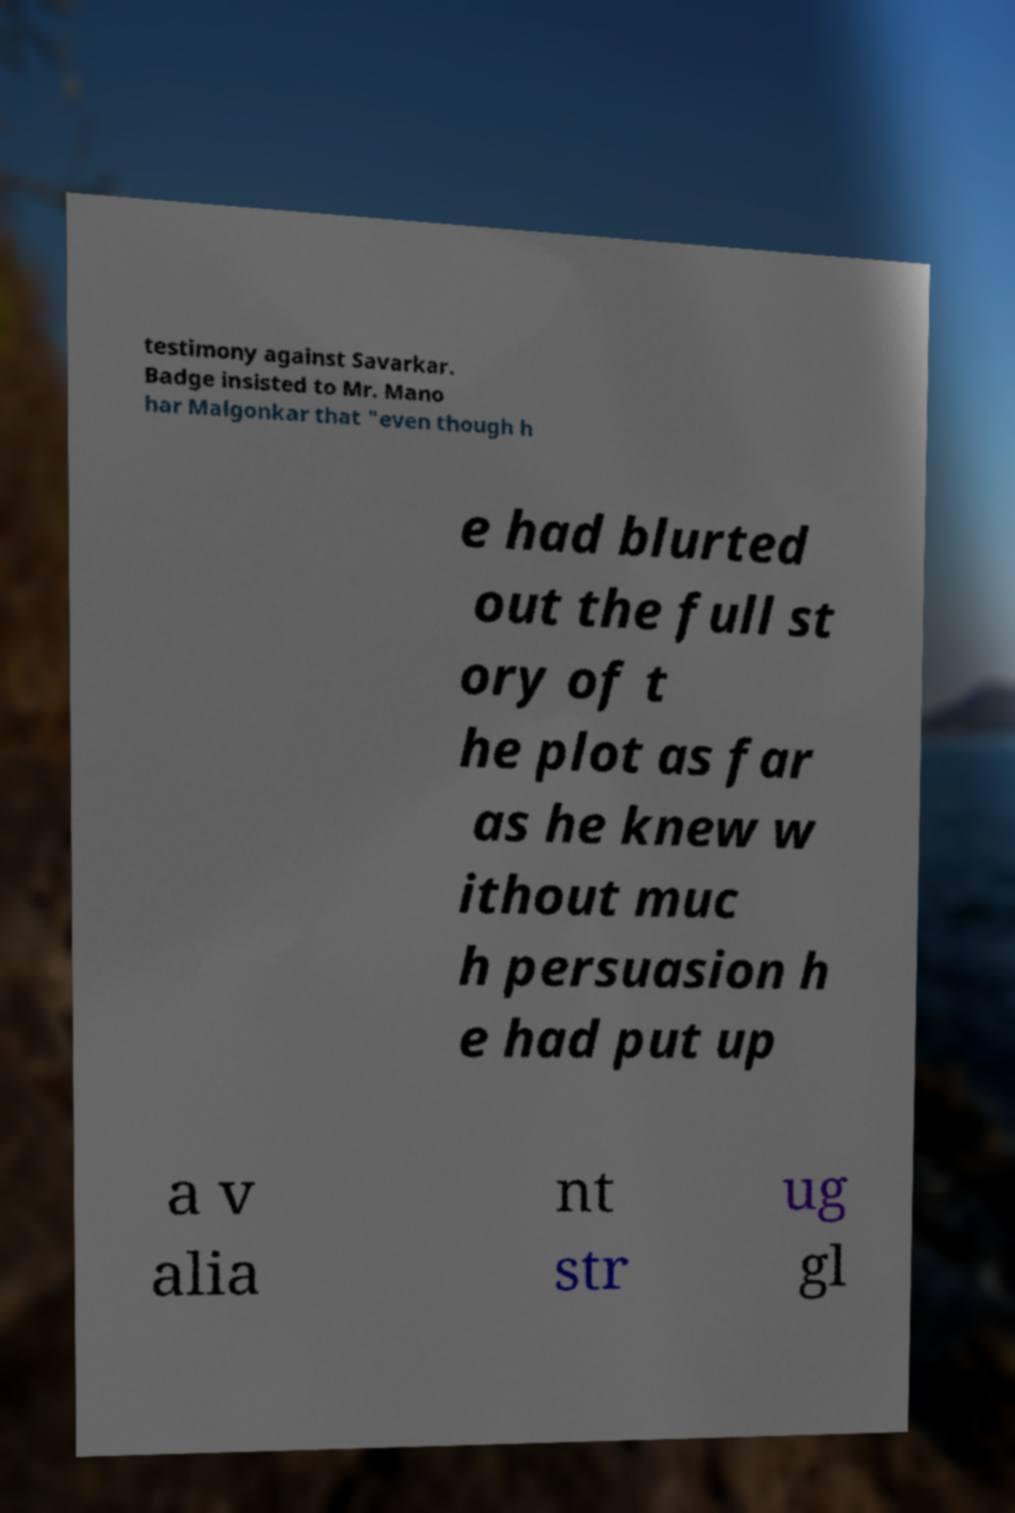Can you read and provide the text displayed in the image?This photo seems to have some interesting text. Can you extract and type it out for me? testimony against Savarkar. Badge insisted to Mr. Mano har Malgonkar that "even though h e had blurted out the full st ory of t he plot as far as he knew w ithout muc h persuasion h e had put up a v alia nt str ug gl 